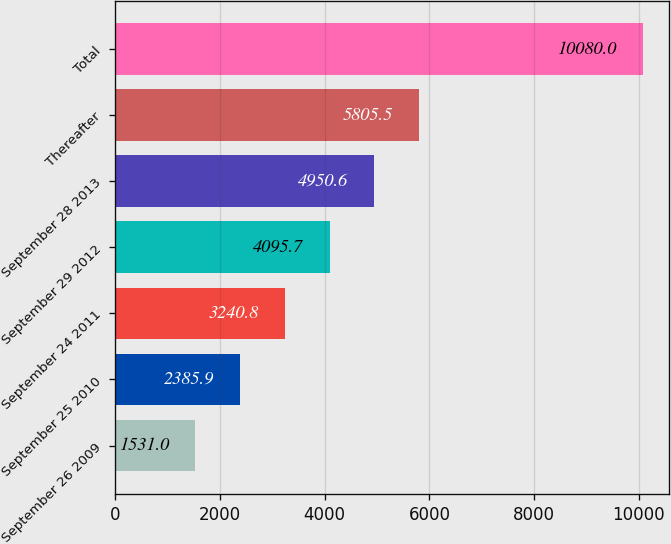Convert chart to OTSL. <chart><loc_0><loc_0><loc_500><loc_500><bar_chart><fcel>September 26 2009<fcel>September 25 2010<fcel>September 24 2011<fcel>September 29 2012<fcel>September 28 2013<fcel>Thereafter<fcel>Total<nl><fcel>1531<fcel>2385.9<fcel>3240.8<fcel>4095.7<fcel>4950.6<fcel>5805.5<fcel>10080<nl></chart> 